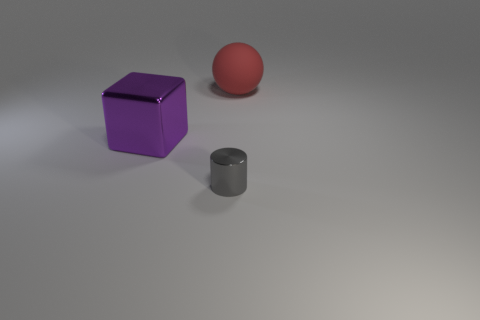Is there any other thing that has the same size as the gray metal object?
Your answer should be very brief. No. Is there anything else that is the same shape as the red rubber object?
Your answer should be very brief. No. What color is the metal cylinder?
Your answer should be compact. Gray. What number of other gray shiny objects have the same shape as the tiny metallic thing?
Your answer should be compact. 0. What color is the metal cube that is the same size as the red thing?
Your response must be concise. Purple. Are any gray matte things visible?
Keep it short and to the point. No. The large thing on the left side of the tiny gray cylinder has what shape?
Your response must be concise. Cube. What number of objects are both to the left of the red object and right of the metal block?
Offer a very short reply. 1. Are there any purple things made of the same material as the cylinder?
Provide a short and direct response. Yes. How many balls are large metal things or big cyan matte objects?
Provide a short and direct response. 0. 